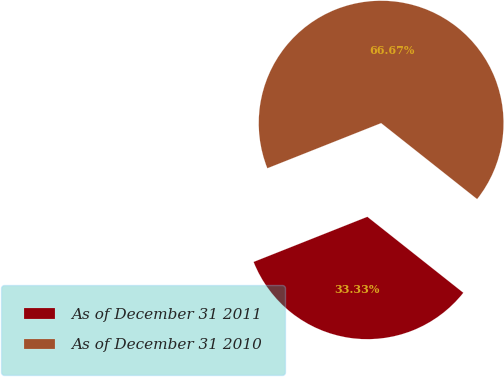Convert chart to OTSL. <chart><loc_0><loc_0><loc_500><loc_500><pie_chart><fcel>As of December 31 2011<fcel>As of December 31 2010<nl><fcel>33.33%<fcel>66.67%<nl></chart> 